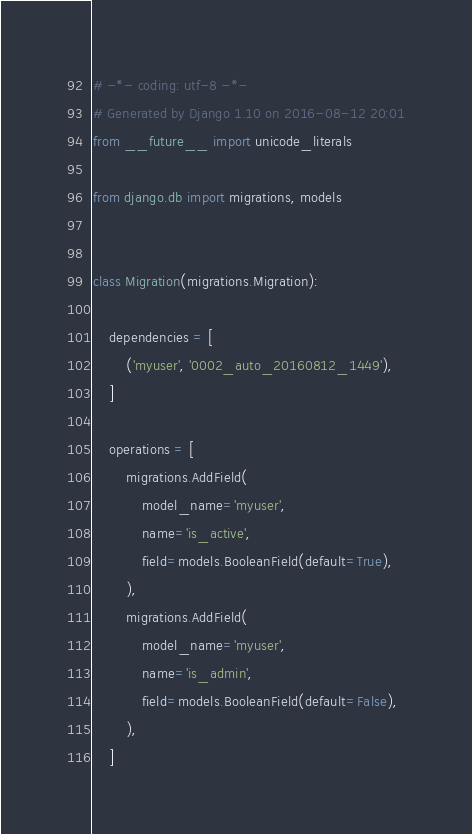Convert code to text. <code><loc_0><loc_0><loc_500><loc_500><_Python_># -*- coding: utf-8 -*-
# Generated by Django 1.10 on 2016-08-12 20:01
from __future__ import unicode_literals

from django.db import migrations, models


class Migration(migrations.Migration):

    dependencies = [
        ('myuser', '0002_auto_20160812_1449'),
    ]

    operations = [
        migrations.AddField(
            model_name='myuser',
            name='is_active',
            field=models.BooleanField(default=True),
        ),
        migrations.AddField(
            model_name='myuser',
            name='is_admin',
            field=models.BooleanField(default=False),
        ),
    ]
</code> 